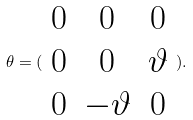Convert formula to latex. <formula><loc_0><loc_0><loc_500><loc_500>\theta = ( \begin{array} { c c c } 0 & 0 & 0 \\ 0 & 0 & \vartheta \\ 0 & - \vartheta & 0 \end{array} ) .</formula> 